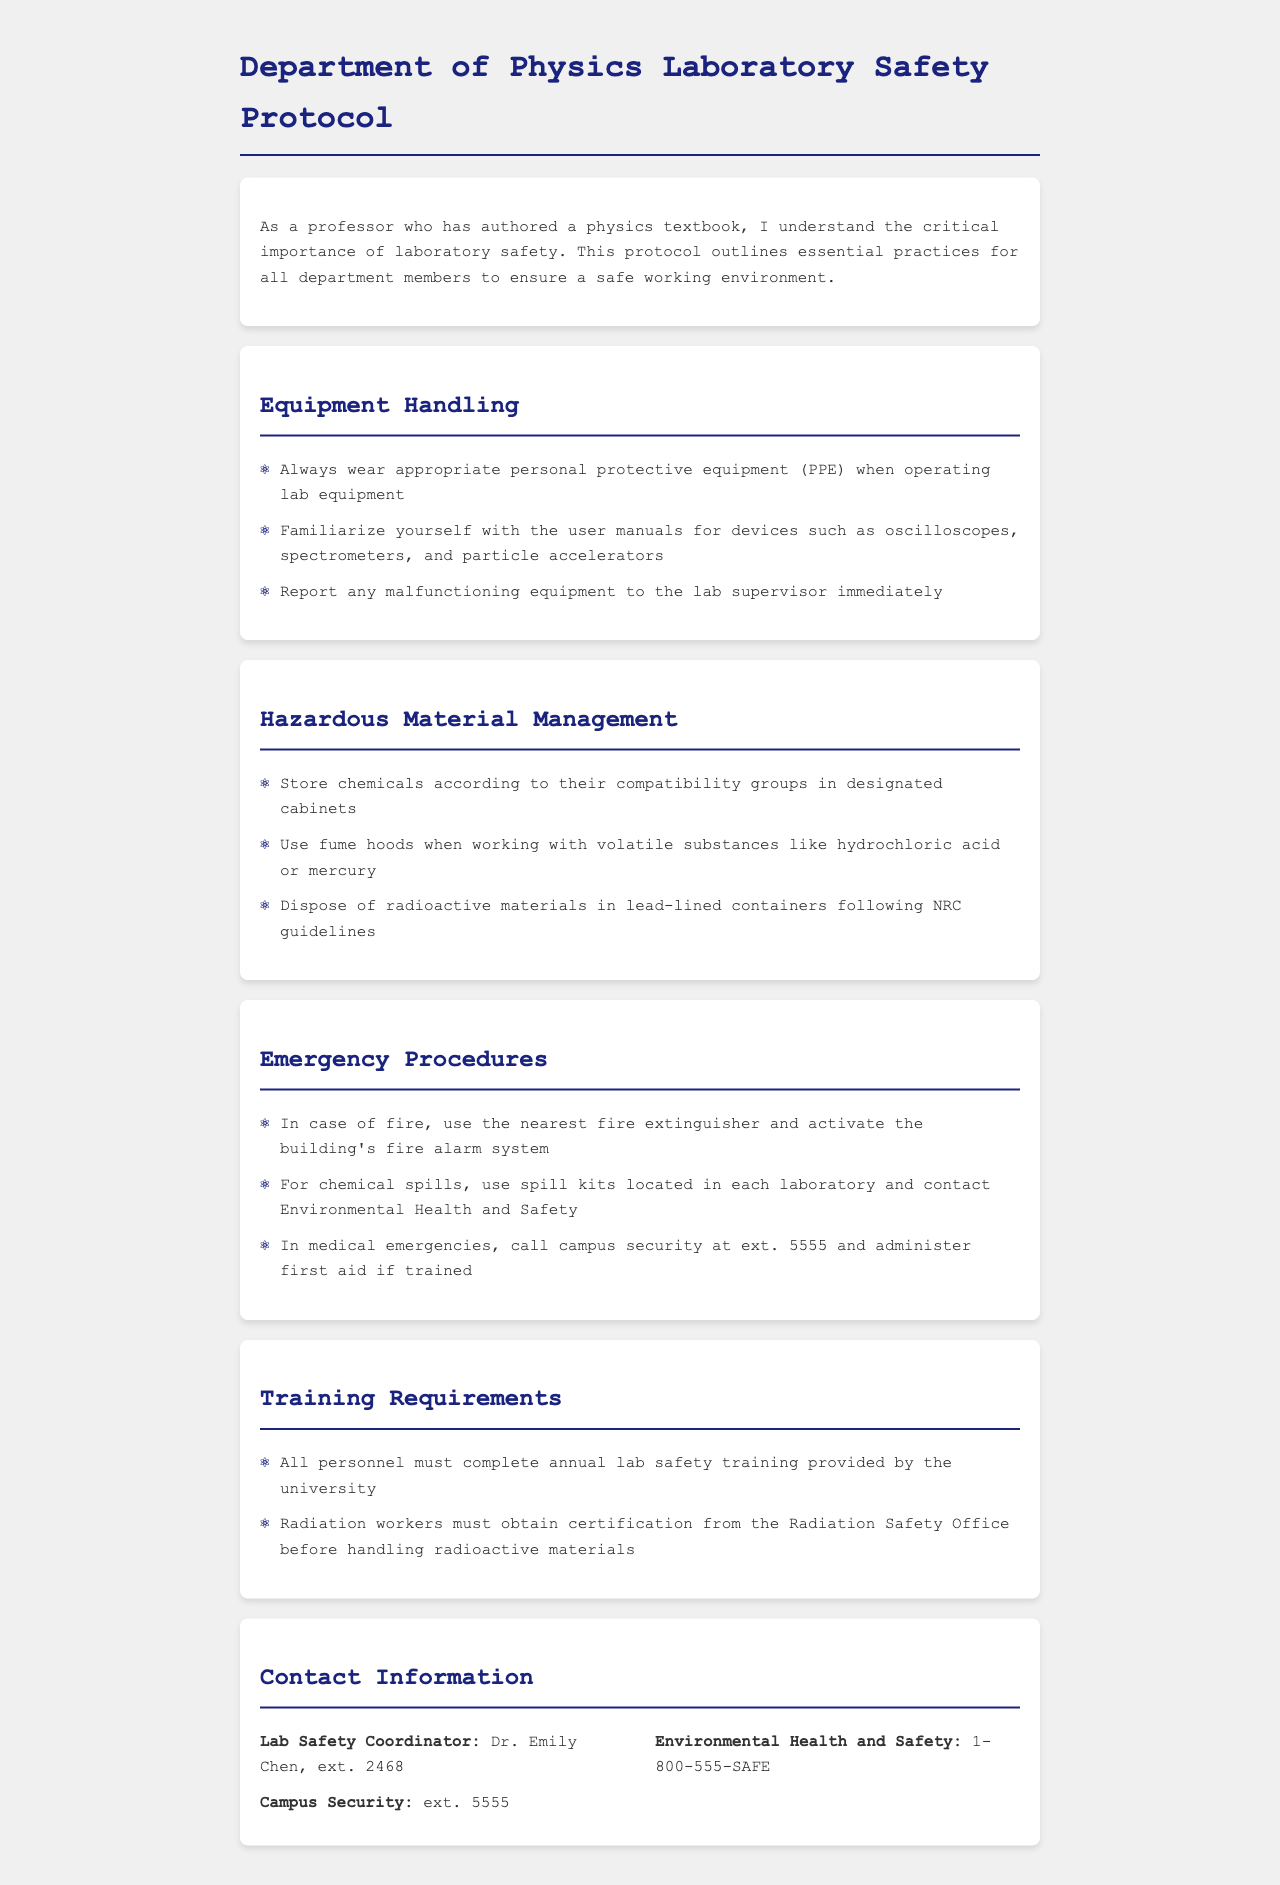What is the purpose of the document? The document outlines essential practices for all department members to ensure a safe working environment.
Answer: Ensuring a safe working environment Who is the Lab Safety Coordinator? The document specifies who to contact for lab safety issues.
Answer: Dr. Emily Chen What equipment must personnel familiarize themselves with? The document lists specific equipment for which user manuals must be reviewed.
Answer: Oscilloscopes, spectrometers, and particle accelerators What should you do in case of a fire? The document provides specific actions to take during a fire emergency.
Answer: Use the nearest fire extinguisher Where should hazardous chemicals be stored? The policy outlines the storage practice for hazardous materials.
Answer: Designated cabinets How often must personnel complete lab safety training? The document specifies the frequency of mandatory training.
Answer: Annually What type of certification is required for radiation workers? The document states the type of certification needed before handling certain materials.
Answer: Certification from the Radiation Safety Office What should be done during a chemical spill? The document describes the immediate response for chemical spills.
Answer: Use spill kits and contact Environmental Health and Safety What number should be called for medical emergencies? The document provides a specific contact for medical emergencies.
Answer: ext. 5555 